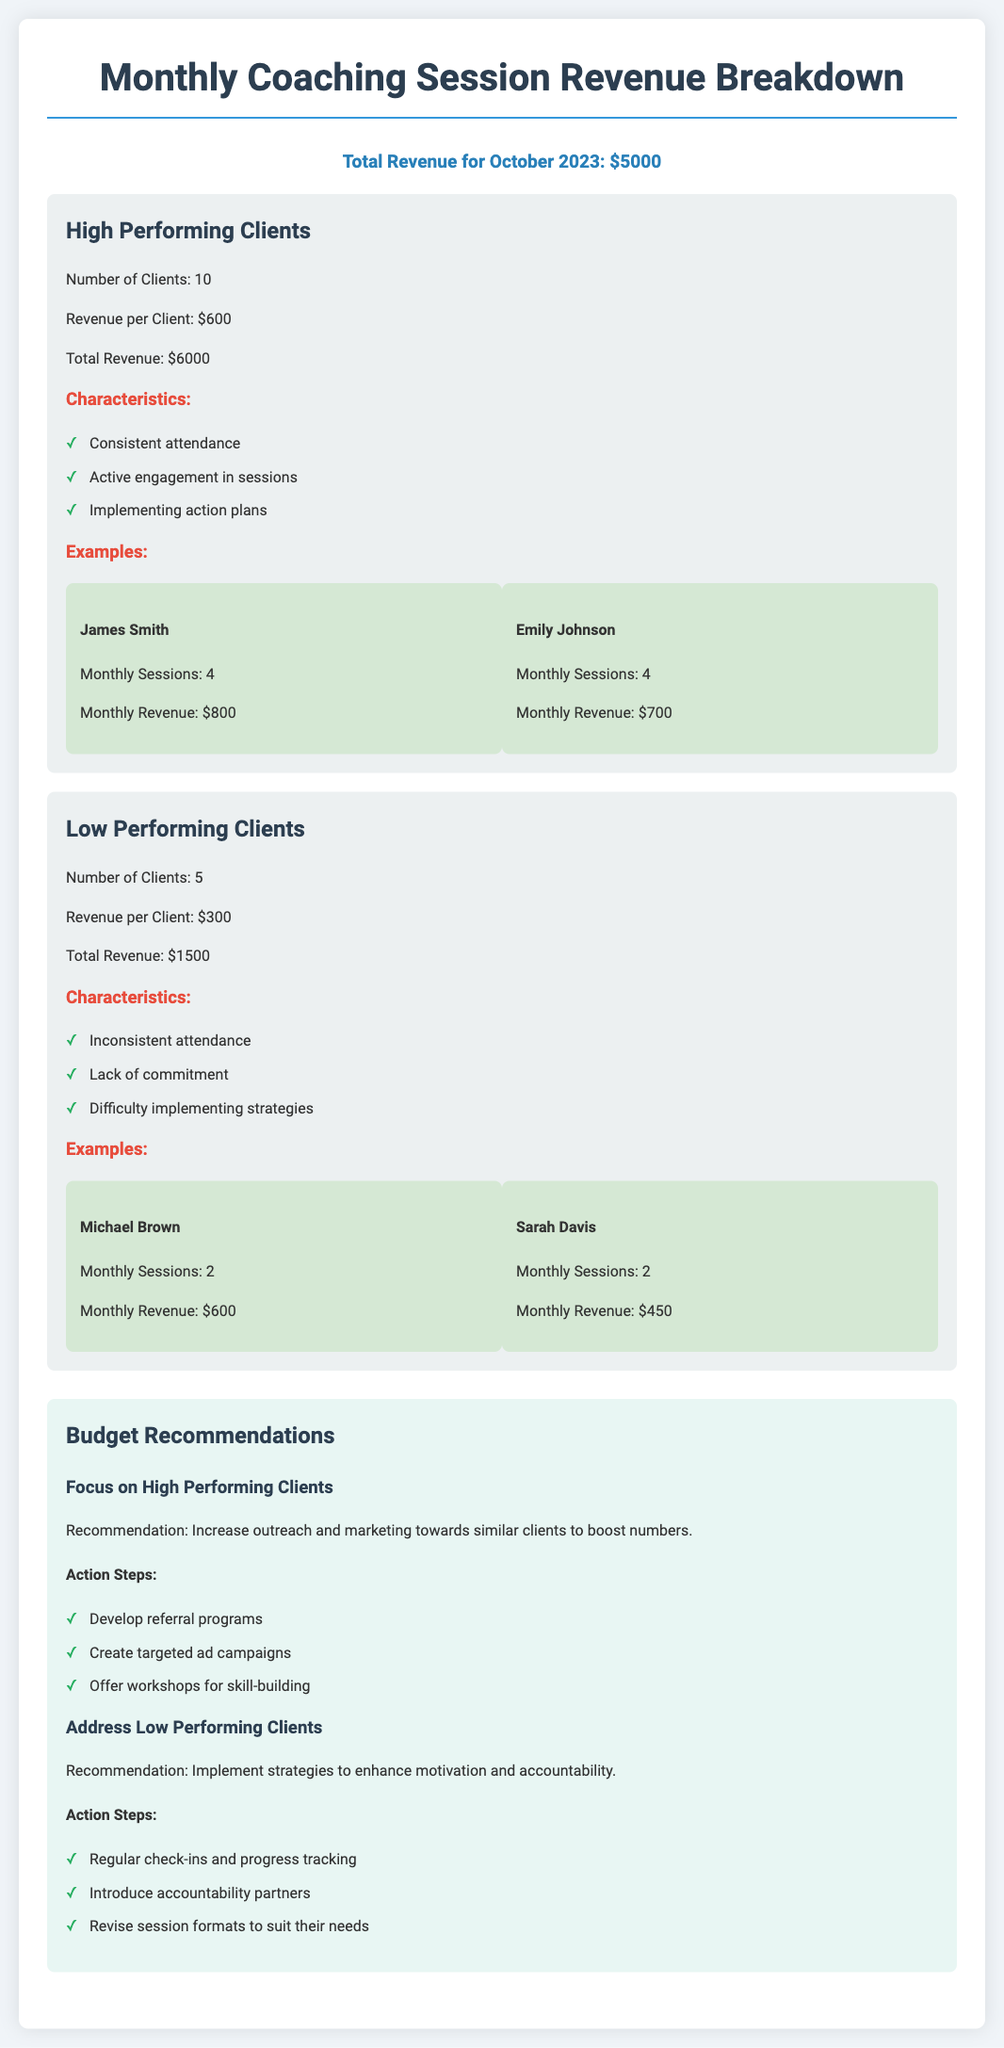What is the total revenue for October 2023? The total revenue for October 2023 is mentioned at the top of the document.
Answer: $5000 How many high performing clients are there? The number of high performing clients is listed in the section for high performing clients.
Answer: 10 What is the revenue per low performing client? The revenue per client in the low performing category is specified in the low performing clients section.
Answer: $300 Who is an example of a high performing client? An example from the high performing client section is presented with a name and relevant details.
Answer: James Smith What is one characteristic of low performing clients? A characteristic of low performing clients is listed in the low performing clients section.
Answer: Inconsistent attendance What recommendation is made for high performing clients? The recommendation for high performing clients can be found in the budget recommendations section.
Answer: Increase outreach and marketing How many total sessions did Michael Brown have? The total number of sessions for Michael Brown is specified in the low performing clients section.
Answer: 2 What is the total revenue from low performing clients? The total revenue for low performing clients is mentioned in the budget breakdown section.
Answer: $1500 What action step is recommended for low performing clients? An action step for low performing clients is detailed in the recommendations section.
Answer: Regular check-ins and progress tracking 